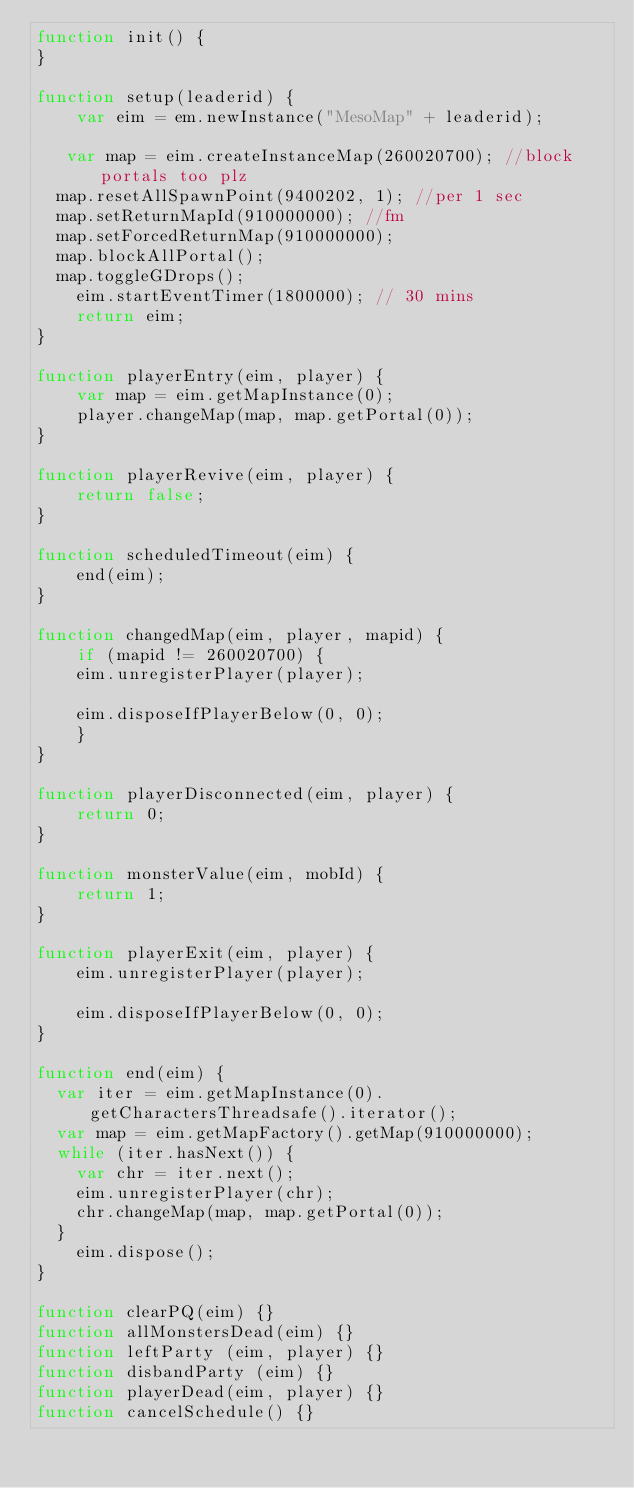Convert code to text. <code><loc_0><loc_0><loc_500><loc_500><_JavaScript_>function init() {
}

function setup(leaderid) {
    var eim = em.newInstance("MesoMap" + leaderid);

   var map = eim.createInstanceMap(260020700); //block portals too plz
	map.resetAllSpawnPoint(9400202, 1); //per 1 sec
	map.setReturnMapId(910000000); //fm
	map.setForcedReturnMap(910000000);
	map.blockAllPortal();
	map.toggleGDrops();
    eim.startEventTimer(1800000); // 30 mins
    return eim;
}

function playerEntry(eim, player) {
    var map = eim.getMapInstance(0);
    player.changeMap(map, map.getPortal(0));
}

function playerRevive(eim, player) {
    return false;
}

function scheduledTimeout(eim) {
    end(eim);
}

function changedMap(eim, player, mapid) {
    if (mapid != 260020700) {
    eim.unregisterPlayer(player);

    eim.disposeIfPlayerBelow(0, 0);
    }
}

function playerDisconnected(eim, player) {
    return 0;
}

function monsterValue(eim, mobId) {
    return 1;
}

function playerExit(eim, player) {
    eim.unregisterPlayer(player);

    eim.disposeIfPlayerBelow(0, 0);
}

function end(eim) {
	var iter = eim.getMapInstance(0).getCharactersThreadsafe().iterator();
	var map = eim.getMapFactory().getMap(910000000);
	while (iter.hasNext()) {
		var chr = iter.next();
		eim.unregisterPlayer(chr);
		chr.changeMap(map, map.getPortal(0));
	}
    eim.dispose();
}

function clearPQ(eim) {}
function allMonstersDead(eim) {}
function leftParty (eim, player) {}
function disbandParty (eim) {}
function playerDead(eim, player) {}
function cancelSchedule() {}</code> 